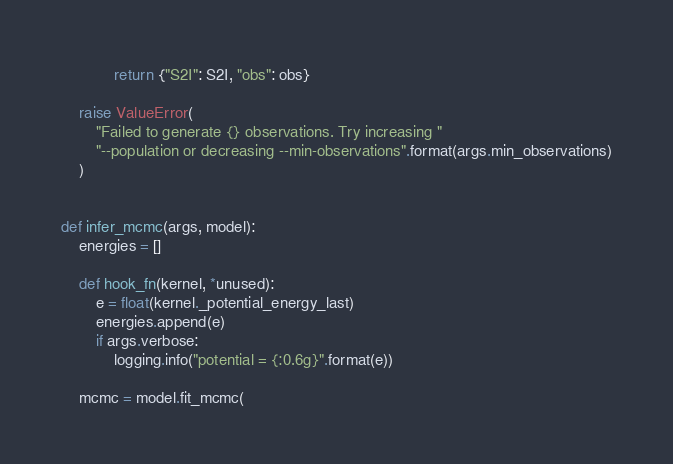Convert code to text. <code><loc_0><loc_0><loc_500><loc_500><_Python_>            return {"S2I": S2I, "obs": obs}

    raise ValueError(
        "Failed to generate {} observations. Try increasing "
        "--population or decreasing --min-observations".format(args.min_observations)
    )


def infer_mcmc(args, model):
    energies = []

    def hook_fn(kernel, *unused):
        e = float(kernel._potential_energy_last)
        energies.append(e)
        if args.verbose:
            logging.info("potential = {:0.6g}".format(e))

    mcmc = model.fit_mcmc(</code> 